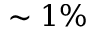<formula> <loc_0><loc_0><loc_500><loc_500>\sim 1 \%</formula> 